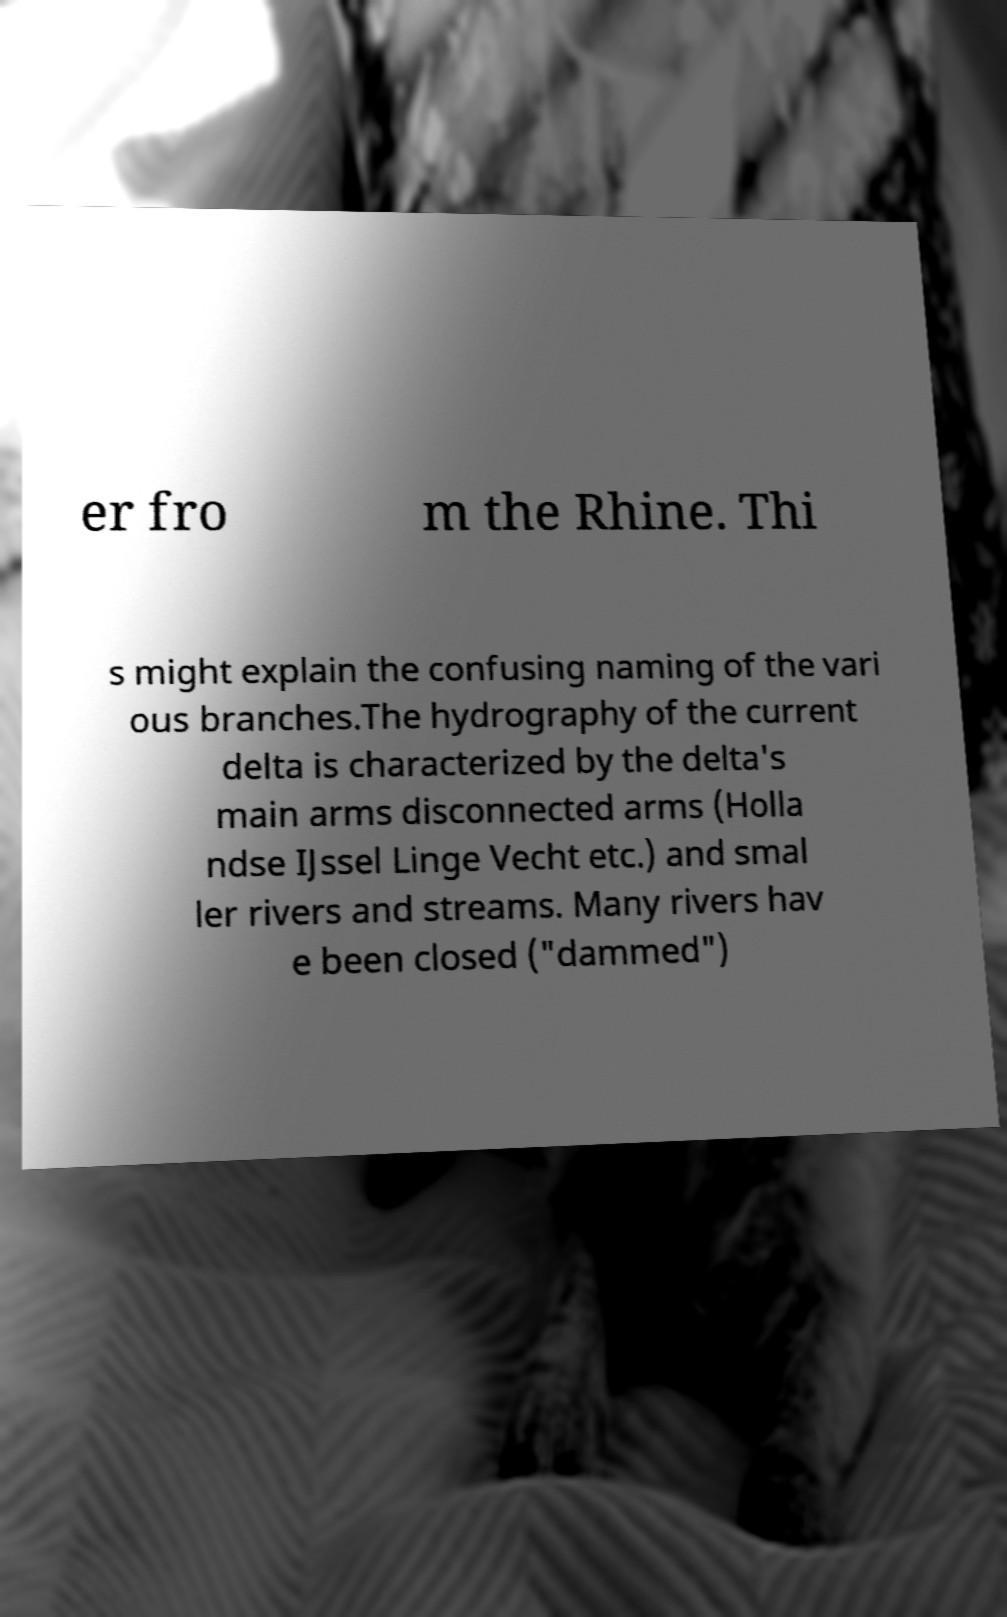Can you accurately transcribe the text from the provided image for me? er fro m the Rhine. Thi s might explain the confusing naming of the vari ous branches.The hydrography of the current delta is characterized by the delta's main arms disconnected arms (Holla ndse IJssel Linge Vecht etc.) and smal ler rivers and streams. Many rivers hav e been closed ("dammed") 